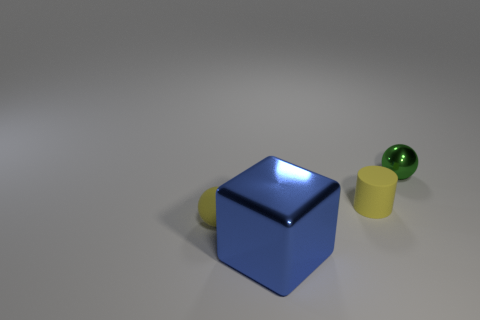Add 1 small matte things. How many objects exist? 5 Subtract all cubes. How many objects are left? 3 Add 3 rubber balls. How many rubber balls are left? 4 Add 4 big brown rubber cylinders. How many big brown rubber cylinders exist? 4 Subtract 0 green cylinders. How many objects are left? 4 Subtract all cylinders. Subtract all big blue cubes. How many objects are left? 2 